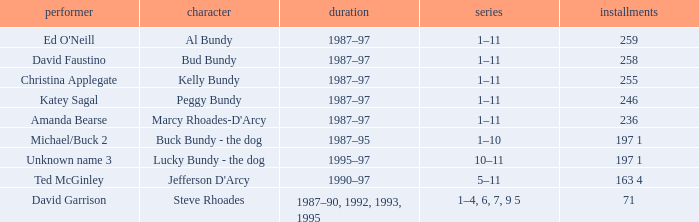How many years did the role of Steve Rhoades last? 1987–90, 1992, 1993, 1995. 